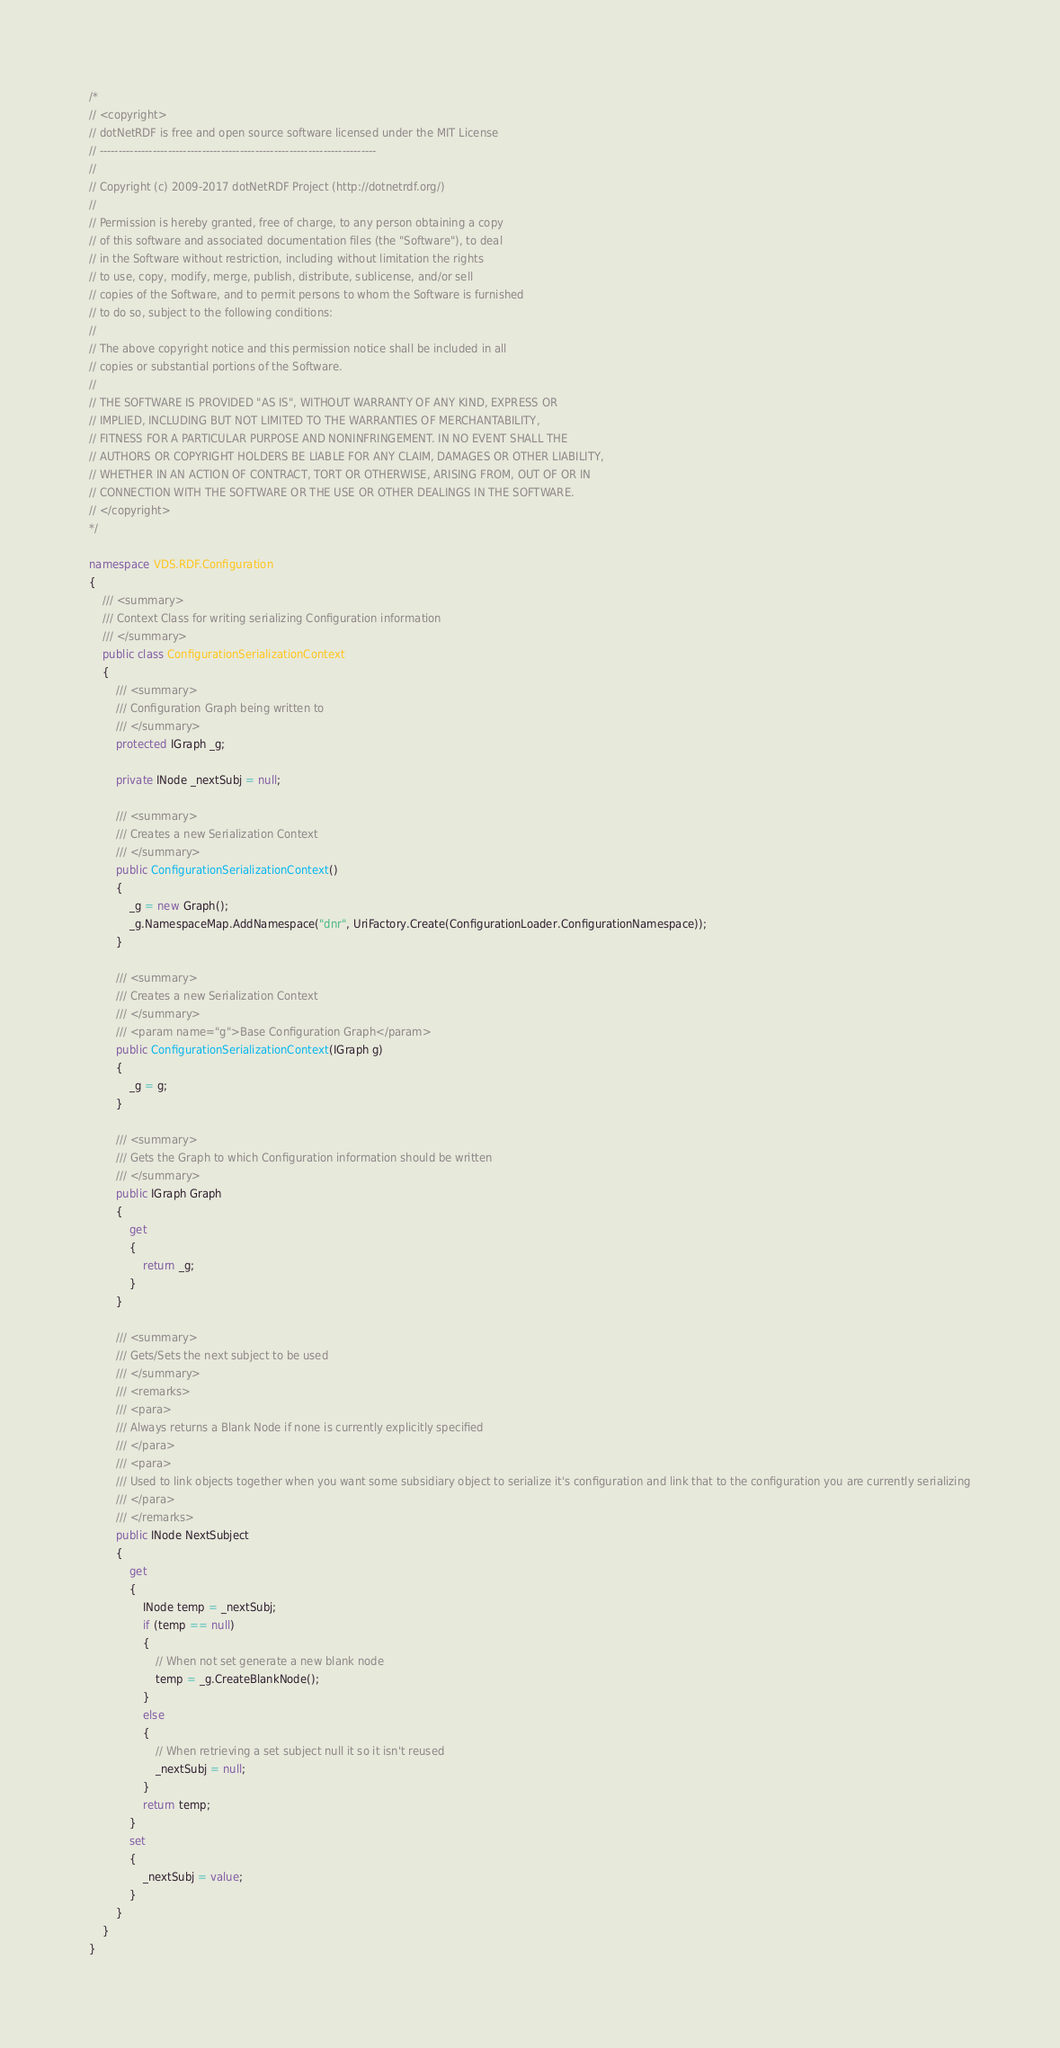Convert code to text. <code><loc_0><loc_0><loc_500><loc_500><_C#_>/*
// <copyright>
// dotNetRDF is free and open source software licensed under the MIT License
// -------------------------------------------------------------------------
// 
// Copyright (c) 2009-2017 dotNetRDF Project (http://dotnetrdf.org/)
// 
// Permission is hereby granted, free of charge, to any person obtaining a copy
// of this software and associated documentation files (the "Software"), to deal
// in the Software without restriction, including without limitation the rights
// to use, copy, modify, merge, publish, distribute, sublicense, and/or sell
// copies of the Software, and to permit persons to whom the Software is furnished
// to do so, subject to the following conditions:
// 
// The above copyright notice and this permission notice shall be included in all
// copies or substantial portions of the Software.
// 
// THE SOFTWARE IS PROVIDED "AS IS", WITHOUT WARRANTY OF ANY KIND, EXPRESS OR 
// IMPLIED, INCLUDING BUT NOT LIMITED TO THE WARRANTIES OF MERCHANTABILITY, 
// FITNESS FOR A PARTICULAR PURPOSE AND NONINFRINGEMENT. IN NO EVENT SHALL THE
// AUTHORS OR COPYRIGHT HOLDERS BE LIABLE FOR ANY CLAIM, DAMAGES OR OTHER LIABILITY,
// WHETHER IN AN ACTION OF CONTRACT, TORT OR OTHERWISE, ARISING FROM, OUT OF OR IN
// CONNECTION WITH THE SOFTWARE OR THE USE OR OTHER DEALINGS IN THE SOFTWARE.
// </copyright>
*/

namespace VDS.RDF.Configuration
{
    /// <summary>
    /// Context Class for writing serializing Configuration information
    /// </summary>
    public class ConfigurationSerializationContext
    {
        /// <summary>
        /// Configuration Graph being written to
        /// </summary>
        protected IGraph _g;

        private INode _nextSubj = null;

        /// <summary>
        /// Creates a new Serialization Context
        /// </summary>
        public ConfigurationSerializationContext()
        {
            _g = new Graph();
            _g.NamespaceMap.AddNamespace("dnr", UriFactory.Create(ConfigurationLoader.ConfigurationNamespace));
        }

        /// <summary>
        /// Creates a new Serialization Context
        /// </summary>
        /// <param name="g">Base Configuration Graph</param>
        public ConfigurationSerializationContext(IGraph g)
        {
            _g = g;
        }

        /// <summary>
        /// Gets the Graph to which Configuration information should be written
        /// </summary>
        public IGraph Graph
        {
            get
            {
                return _g;
            }
        }

        /// <summary>
        /// Gets/Sets the next subject to be used
        /// </summary>
        /// <remarks>
        /// <para>
        /// Always returns a Blank Node if none is currently explicitly specified
        /// </para>
        /// <para>
        /// Used to link objects together when you want some subsidiary object to serialize it's configuration and link that to the configuration you are currently serializing
        /// </para>
        /// </remarks>
        public INode NextSubject
        {
            get
            {
                INode temp = _nextSubj;
                if (temp == null)
                {
                    // When not set generate a new blank node
                    temp = _g.CreateBlankNode();
                }
                else
                {
                    // When retrieving a set subject null it so it isn't reused
                    _nextSubj = null;
                }
                return temp;
            }
            set
            {
                _nextSubj = value;
            }
        }
    }
}
</code> 